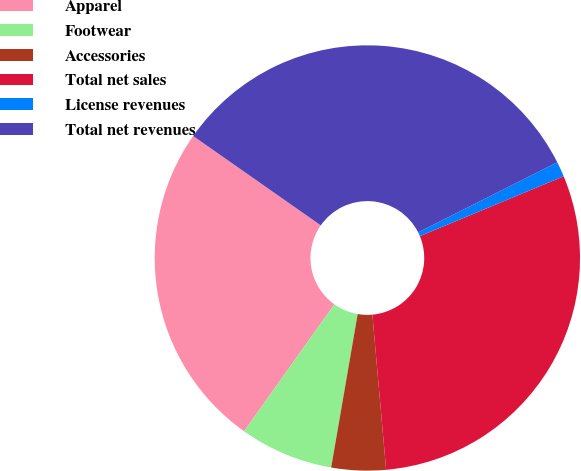Convert chart to OTSL. <chart><loc_0><loc_0><loc_500><loc_500><pie_chart><fcel>Apparel<fcel>Footwear<fcel>Accessories<fcel>Total net sales<fcel>License revenues<fcel>Total net revenues<nl><fcel>24.88%<fcel>7.12%<fcel>4.13%<fcel>29.87%<fcel>1.15%<fcel>32.85%<nl></chart> 